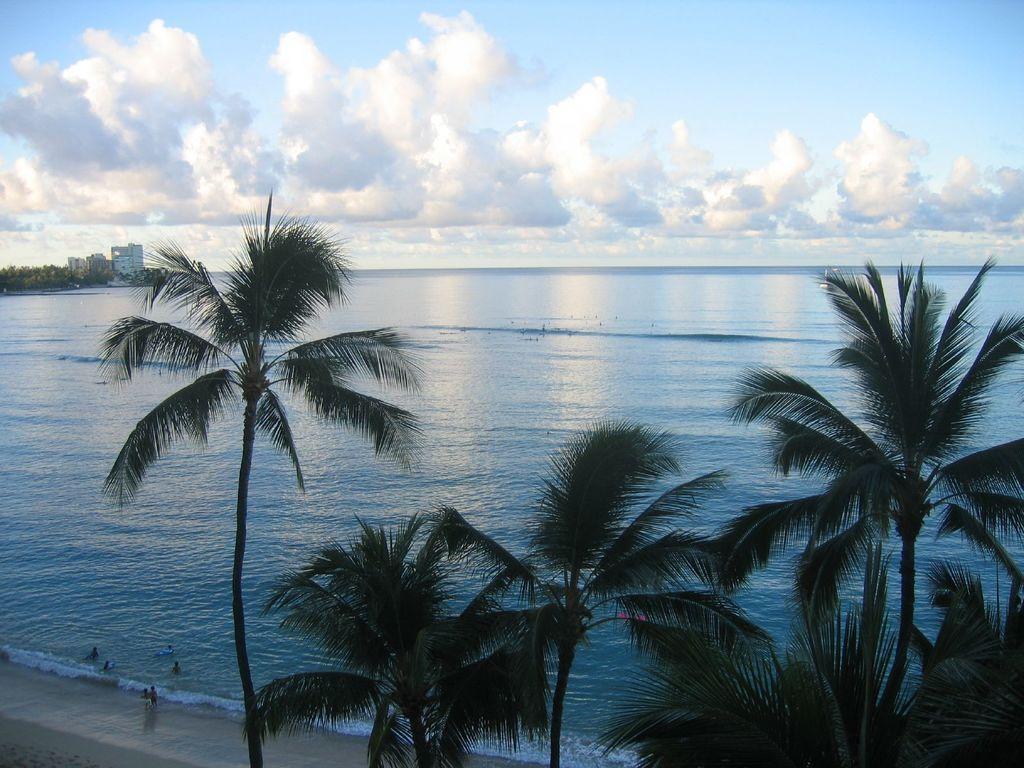How would you summarize this image in a sentence or two? In this image, we can see some trees beside the beach. There are some clouds in the sky. 